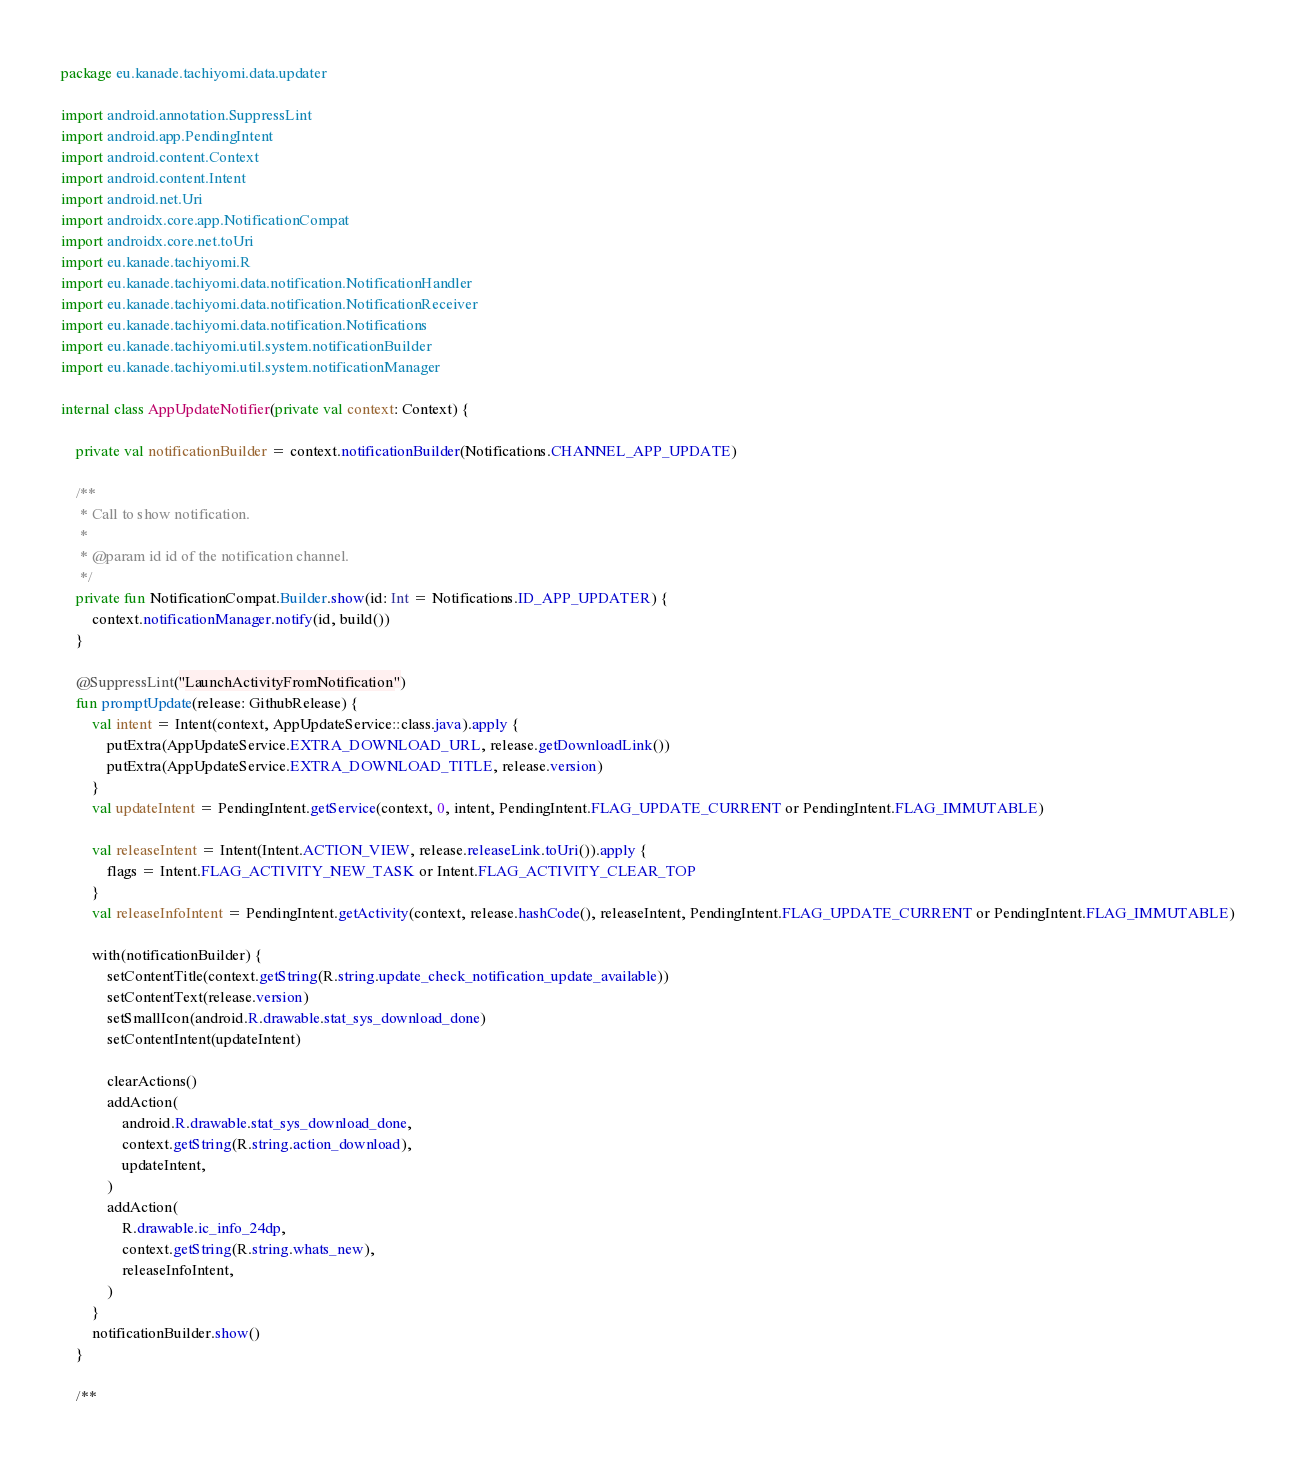<code> <loc_0><loc_0><loc_500><loc_500><_Kotlin_>package eu.kanade.tachiyomi.data.updater

import android.annotation.SuppressLint
import android.app.PendingIntent
import android.content.Context
import android.content.Intent
import android.net.Uri
import androidx.core.app.NotificationCompat
import androidx.core.net.toUri
import eu.kanade.tachiyomi.R
import eu.kanade.tachiyomi.data.notification.NotificationHandler
import eu.kanade.tachiyomi.data.notification.NotificationReceiver
import eu.kanade.tachiyomi.data.notification.Notifications
import eu.kanade.tachiyomi.util.system.notificationBuilder
import eu.kanade.tachiyomi.util.system.notificationManager

internal class AppUpdateNotifier(private val context: Context) {

    private val notificationBuilder = context.notificationBuilder(Notifications.CHANNEL_APP_UPDATE)

    /**
     * Call to show notification.
     *
     * @param id id of the notification channel.
     */
    private fun NotificationCompat.Builder.show(id: Int = Notifications.ID_APP_UPDATER) {
        context.notificationManager.notify(id, build())
    }

    @SuppressLint("LaunchActivityFromNotification")
    fun promptUpdate(release: GithubRelease) {
        val intent = Intent(context, AppUpdateService::class.java).apply {
            putExtra(AppUpdateService.EXTRA_DOWNLOAD_URL, release.getDownloadLink())
            putExtra(AppUpdateService.EXTRA_DOWNLOAD_TITLE, release.version)
        }
        val updateIntent = PendingIntent.getService(context, 0, intent, PendingIntent.FLAG_UPDATE_CURRENT or PendingIntent.FLAG_IMMUTABLE)

        val releaseIntent = Intent(Intent.ACTION_VIEW, release.releaseLink.toUri()).apply {
            flags = Intent.FLAG_ACTIVITY_NEW_TASK or Intent.FLAG_ACTIVITY_CLEAR_TOP
        }
        val releaseInfoIntent = PendingIntent.getActivity(context, release.hashCode(), releaseIntent, PendingIntent.FLAG_UPDATE_CURRENT or PendingIntent.FLAG_IMMUTABLE)

        with(notificationBuilder) {
            setContentTitle(context.getString(R.string.update_check_notification_update_available))
            setContentText(release.version)
            setSmallIcon(android.R.drawable.stat_sys_download_done)
            setContentIntent(updateIntent)

            clearActions()
            addAction(
                android.R.drawable.stat_sys_download_done,
                context.getString(R.string.action_download),
                updateIntent,
            )
            addAction(
                R.drawable.ic_info_24dp,
                context.getString(R.string.whats_new),
                releaseInfoIntent,
            )
        }
        notificationBuilder.show()
    }

    /**</code> 